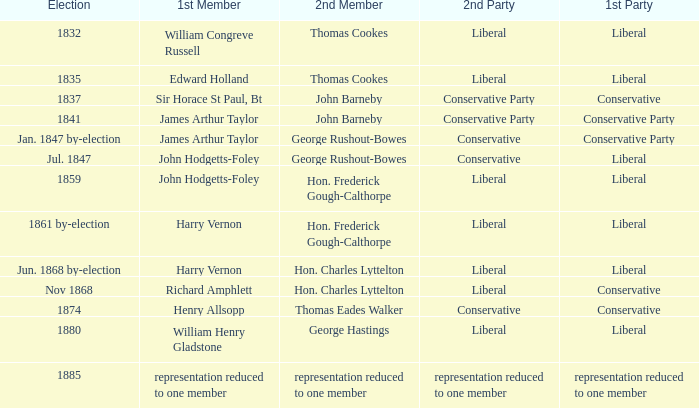Who was the foremost member when the original party experienced a reduction in representation to just one member? Representation reduced to one member. 